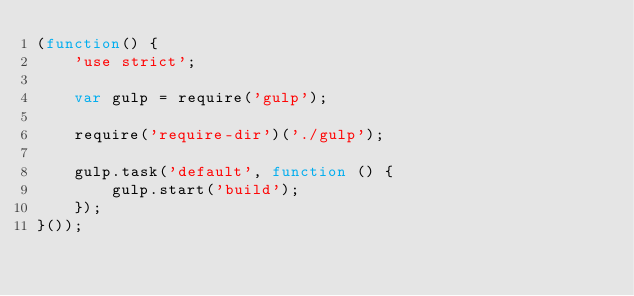<code> <loc_0><loc_0><loc_500><loc_500><_JavaScript_>(function() {
    'use strict';

    var gulp = require('gulp');

    require('require-dir')('./gulp');

    gulp.task('default', function () {
        gulp.start('build');
    });
}());</code> 